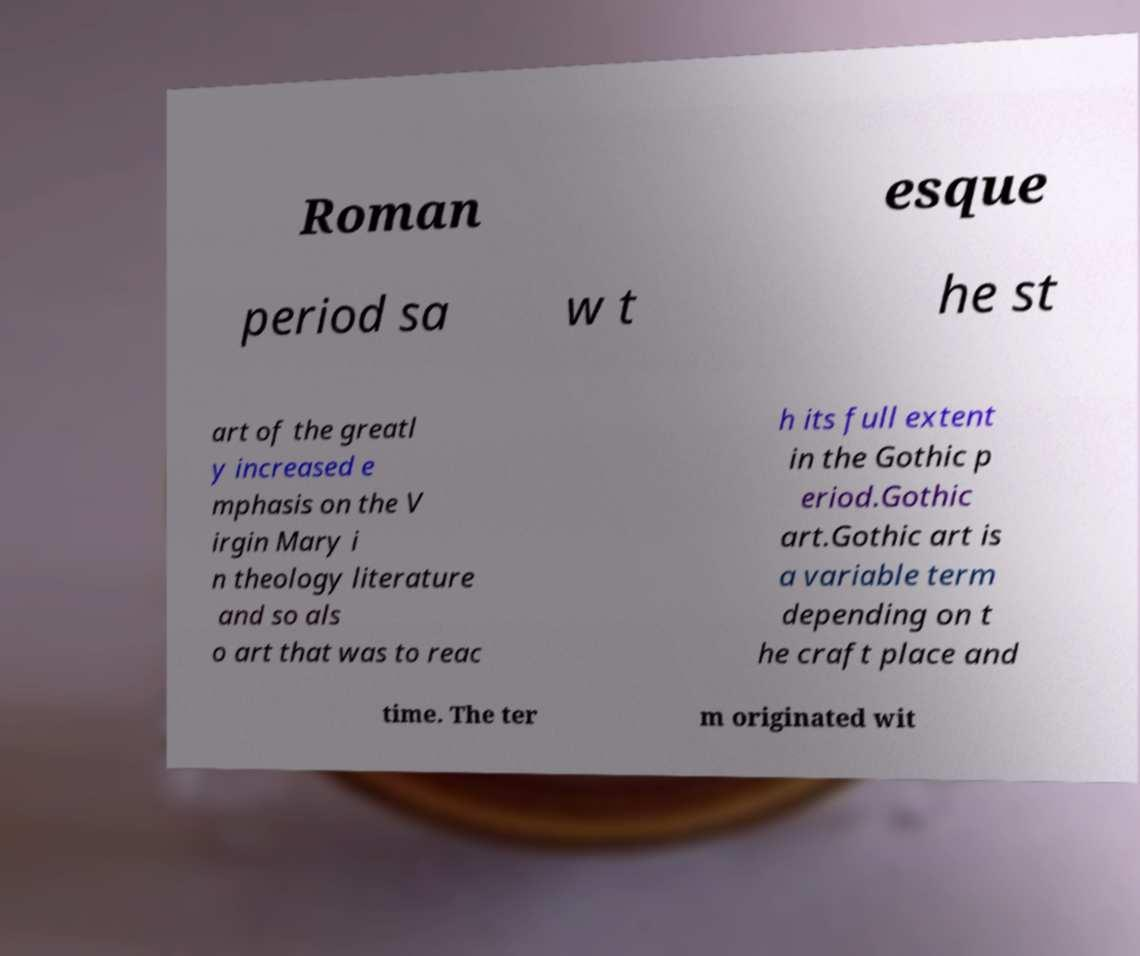Can you read and provide the text displayed in the image?This photo seems to have some interesting text. Can you extract and type it out for me? Roman esque period sa w t he st art of the greatl y increased e mphasis on the V irgin Mary i n theology literature and so als o art that was to reac h its full extent in the Gothic p eriod.Gothic art.Gothic art is a variable term depending on t he craft place and time. The ter m originated wit 